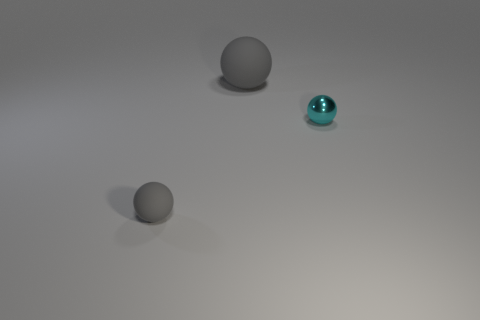Is there a gray rubber sphere that has the same size as the cyan sphere?
Your answer should be compact. Yes. Are there more gray things that are behind the cyan metallic sphere than rubber cylinders?
Provide a short and direct response. Yes. What number of small objects are either blue cubes or balls?
Your answer should be compact. 2. What number of other large things have the same shape as the big rubber thing?
Keep it short and to the point. 0. There is a gray sphere that is on the right side of the gray matte ball in front of the big gray matte sphere; what is it made of?
Make the answer very short. Rubber. What size is the gray sphere behind the cyan metallic sphere?
Ensure brevity in your answer.  Large. How many gray things are either big rubber spheres or matte objects?
Keep it short and to the point. 2. Is there anything else that has the same material as the small cyan thing?
Your response must be concise. No. What material is the small gray object that is the same shape as the tiny cyan thing?
Your response must be concise. Rubber. Is the number of small gray matte things that are right of the small shiny sphere the same as the number of green matte cylinders?
Give a very brief answer. Yes. 